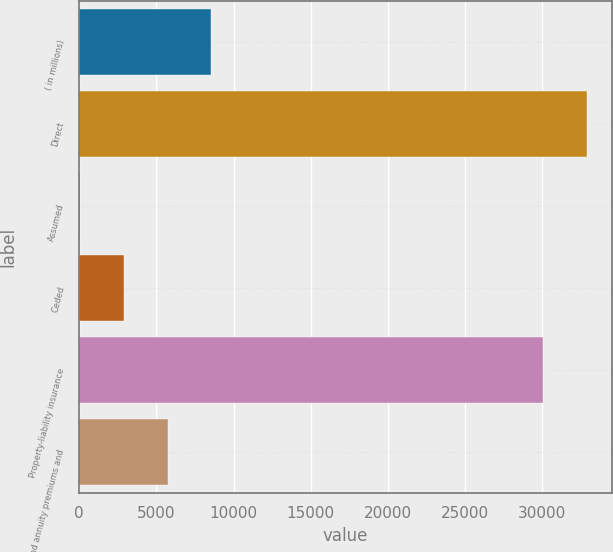Convert chart to OTSL. <chart><loc_0><loc_0><loc_500><loc_500><bar_chart><fcel>( in millions)<fcel>Direct<fcel>Assumed<fcel>Ceded<fcel>Property-liability insurance<fcel>Life and annuity premiums and<nl><fcel>8568.2<fcel>32855.8<fcel>59<fcel>2895.4<fcel>30019.4<fcel>5731.8<nl></chart> 